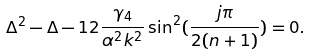<formula> <loc_0><loc_0><loc_500><loc_500>\Delta ^ { 2 } - \Delta - 1 2 \frac { \gamma _ { 4 } } { \alpha ^ { 2 } k ^ { 2 } } \sin ^ { 2 } ( \frac { j \pi } { 2 ( n + 1 ) } ) = 0 .</formula> 